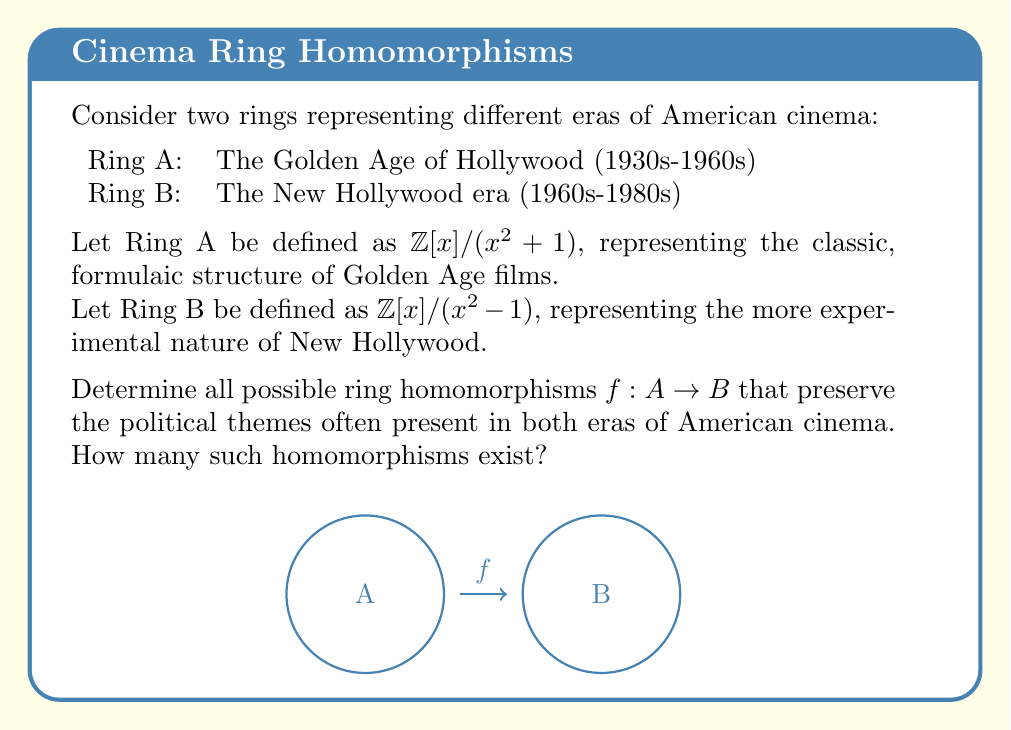Teach me how to tackle this problem. To solve this problem, we need to follow these steps:

1) First, recall that a ring homomorphism $f: A \to B$ must satisfy:
   a) $f(a + b) = f(a) + f(b)$
   b) $f(ab) = f(a)f(b)$
   c) $f(1_A) = 1_B$

2) In Ring A, every element can be written as $a + bx$ where $a, b \in \mathbb{Z}$ and $x^2 = -1$.
   In Ring B, every element can be written as $c + dy$ where $c, d \in \mathbb{Z}$ and $y^2 = 1$.

3) To define a homomorphism, we only need to specify $f(1)$ and $f(x)$, as these generate Ring A.

4) We know $f(1) = 1$ as per property (c) of homomorphisms.

5) Let $f(x) = a + by$ for some $a, b \in \mathbb{Z}$.

6) Now, we use the fact that $x^2 = -1$ in Ring A:
   $f(x^2) = f(-1) = -1$
   But also, $f(x^2) = (f(x))^2 = (a + by)^2 = a^2 + 2aby + b^2y^2 = (a^2 + b^2) + 2aby$

7) Equating these:
   $-1 = (a^2 + b^2) + 2aby$
   This means $a^2 + b^2 = -1$ and $ab = 0$

8) The only integer solutions to these equations are:
   $(a, b) = (0, \pm 1)$ or $(a, b) = (\pm 1, 0)$

9) Therefore, there are four possible homomorphisms:
   $f_1: x \mapsto y$
   $f_2: x \mapsto -y$
   $f_3: x \mapsto 1$
   $f_4: x \mapsto -1$

These homomorphisms preserve the structural transition from the formulaic Golden Age to the more diverse New Hollywood era, while maintaining the underlying integer base that represents the consistent presence of political themes in both periods.
Answer: 4 homomorphisms 